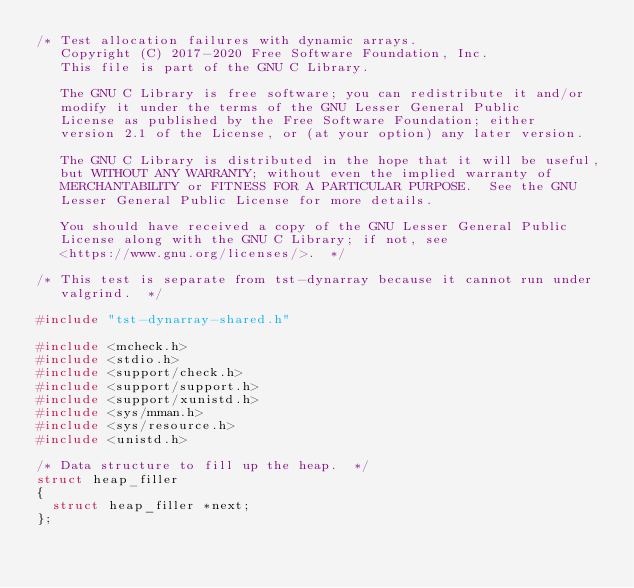<code> <loc_0><loc_0><loc_500><loc_500><_C_>/* Test allocation failures with dynamic arrays.
   Copyright (C) 2017-2020 Free Software Foundation, Inc.
   This file is part of the GNU C Library.

   The GNU C Library is free software; you can redistribute it and/or
   modify it under the terms of the GNU Lesser General Public
   License as published by the Free Software Foundation; either
   version 2.1 of the License, or (at your option) any later version.

   The GNU C Library is distributed in the hope that it will be useful,
   but WITHOUT ANY WARRANTY; without even the implied warranty of
   MERCHANTABILITY or FITNESS FOR A PARTICULAR PURPOSE.  See the GNU
   Lesser General Public License for more details.

   You should have received a copy of the GNU Lesser General Public
   License along with the GNU C Library; if not, see
   <https://www.gnu.org/licenses/>.  */

/* This test is separate from tst-dynarray because it cannot run under
   valgrind.  */

#include "tst-dynarray-shared.h"

#include <mcheck.h>
#include <stdio.h>
#include <support/check.h>
#include <support/support.h>
#include <support/xunistd.h>
#include <sys/mman.h>
#include <sys/resource.h>
#include <unistd.h>

/* Data structure to fill up the heap.  */
struct heap_filler
{
  struct heap_filler *next;
};
</code> 